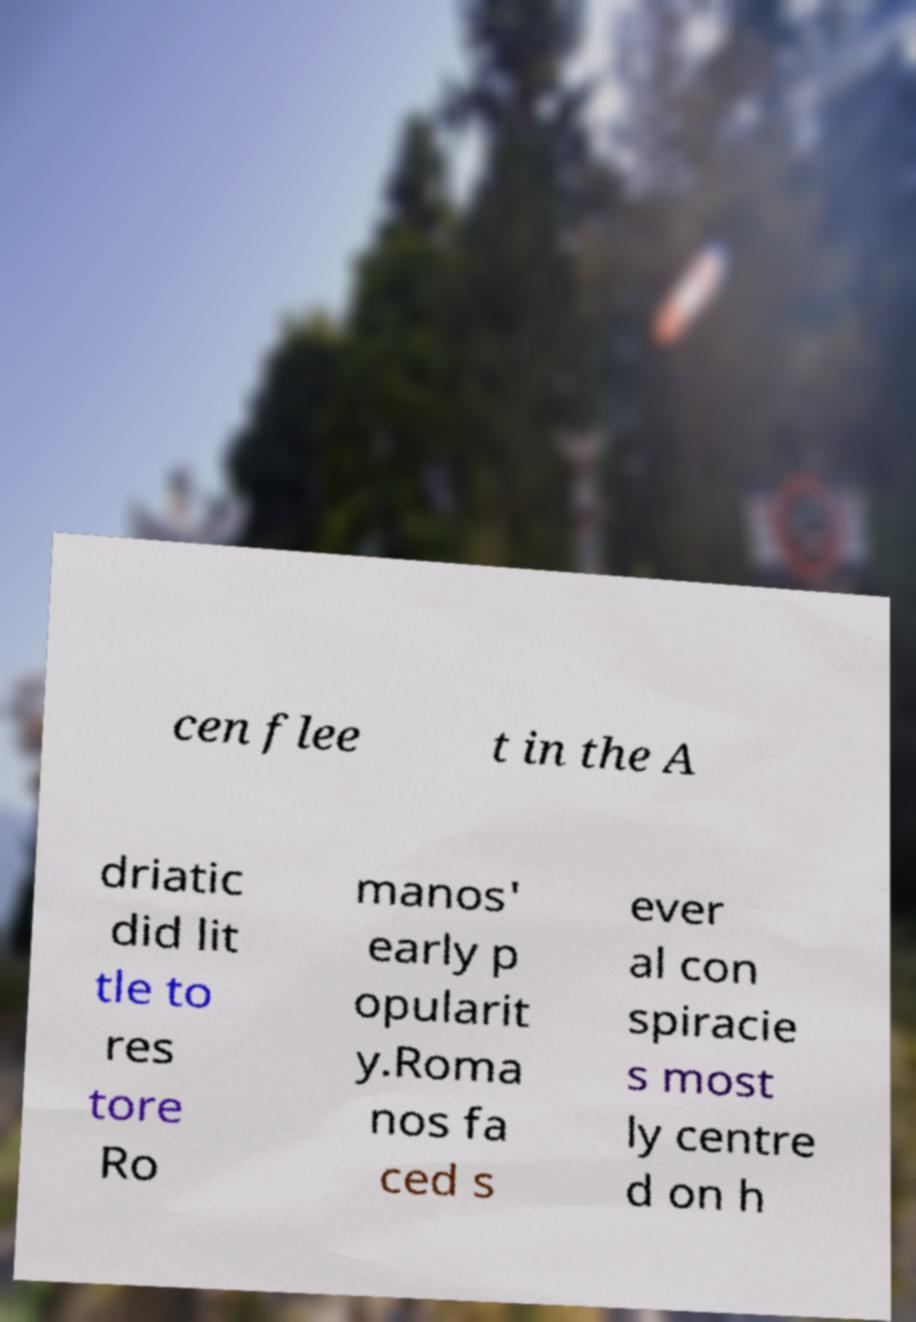For documentation purposes, I need the text within this image transcribed. Could you provide that? cen flee t in the A driatic did lit tle to res tore Ro manos' early p opularit y.Roma nos fa ced s ever al con spiracie s most ly centre d on h 